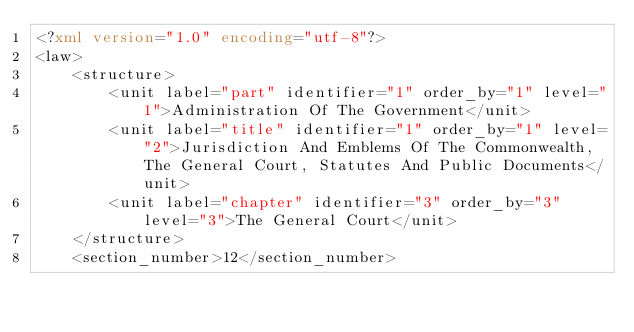Convert code to text. <code><loc_0><loc_0><loc_500><loc_500><_XML_><?xml version="1.0" encoding="utf-8"?>
<law>
    <structure>
        <unit label="part" identifier="1" order_by="1" level="1">Administration Of The Government</unit>
        <unit label="title" identifier="1" order_by="1" level="2">Jurisdiction And Emblems Of The Commonwealth, The General Court, Statutes And Public Documents</unit>
        <unit label="chapter" identifier="3" order_by="3" level="3">The General Court</unit>
    </structure>
    <section_number>12</section_number></code> 